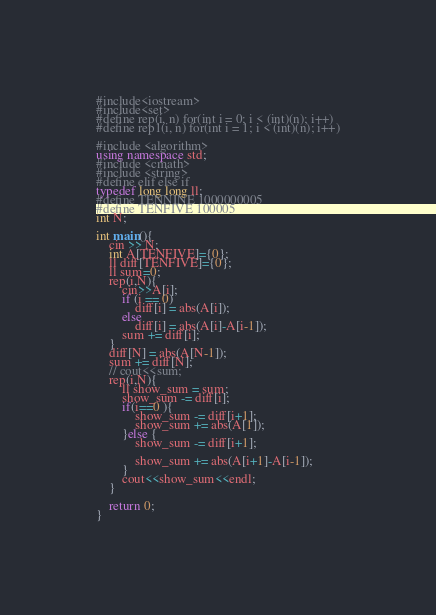<code> <loc_0><loc_0><loc_500><loc_500><_C++_>#include<iostream>
#include<set>
#define rep(i, n) for(int i = 0; i < (int)(n); i++)
#define rep1(i, n) for(int i = 1; i < (int)(n); i++)

#include <algorithm>
using namespace std;
#include <cmath>
#include <string>
#define elif else if
typedef long long ll;
#define TENNINE 1000000005
#define TENFIVE 100005
int N;

int main(){
    cin >> N;
    int A[TENFIVE]={0};
    ll diff[TENFIVE]={0};
    ll sum=0;
    rep(i,N){
        cin>>A[i];
        if (i == 0)    
            diff[i] = abs(A[i]);
        else 
            diff[i] = abs(A[i]-A[i-1]);        
        sum += diff[i];
    }
    diff[N] = abs(A[N-1]);
    sum += diff[N];
    // cout<<sum;
    rep(i,N){ 
        ll show_sum = sum;   
        show_sum -= diff[i];
        if(i==0 ){
            show_sum -= diff[i+1];
            show_sum += abs(A[1]);
        }else {
            show_sum -= diff[i+1];

            show_sum += abs(A[i+1]-A[i-1]);
        }
        cout<<show_sum<<endl;
    }

    return 0;
}</code> 